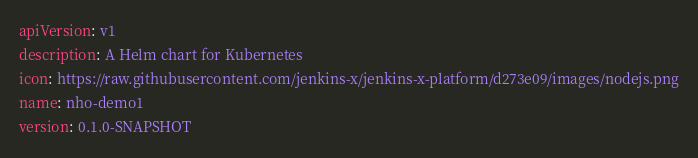<code> <loc_0><loc_0><loc_500><loc_500><_YAML_>apiVersion: v1
description: A Helm chart for Kubernetes
icon: https://raw.githubusercontent.com/jenkins-x/jenkins-x-platform/d273e09/images/nodejs.png
name: nho-demo1
version: 0.1.0-SNAPSHOT
</code> 